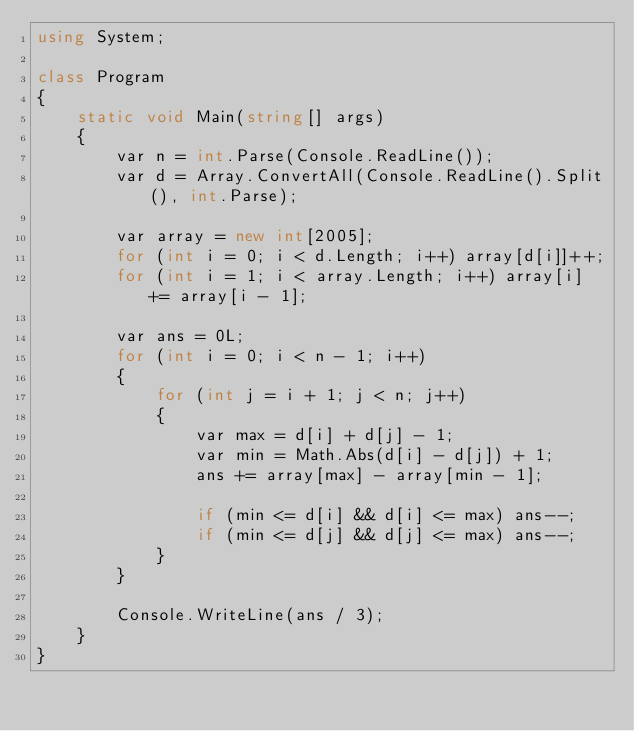<code> <loc_0><loc_0><loc_500><loc_500><_C#_>using System;

class Program
{
    static void Main(string[] args)
    {
        var n = int.Parse(Console.ReadLine());
        var d = Array.ConvertAll(Console.ReadLine().Split(), int.Parse);

        var array = new int[2005];
        for (int i = 0; i < d.Length; i++) array[d[i]]++;
        for (int i = 1; i < array.Length; i++) array[i] += array[i - 1];

        var ans = 0L;
        for (int i = 0; i < n - 1; i++)
        {
            for (int j = i + 1; j < n; j++)
            {
                var max = d[i] + d[j] - 1;
                var min = Math.Abs(d[i] - d[j]) + 1;
                ans += array[max] - array[min - 1];

                if (min <= d[i] && d[i] <= max) ans--;
                if (min <= d[j] && d[j] <= max) ans--;
            }
        }

        Console.WriteLine(ans / 3);
    }
}
</code> 